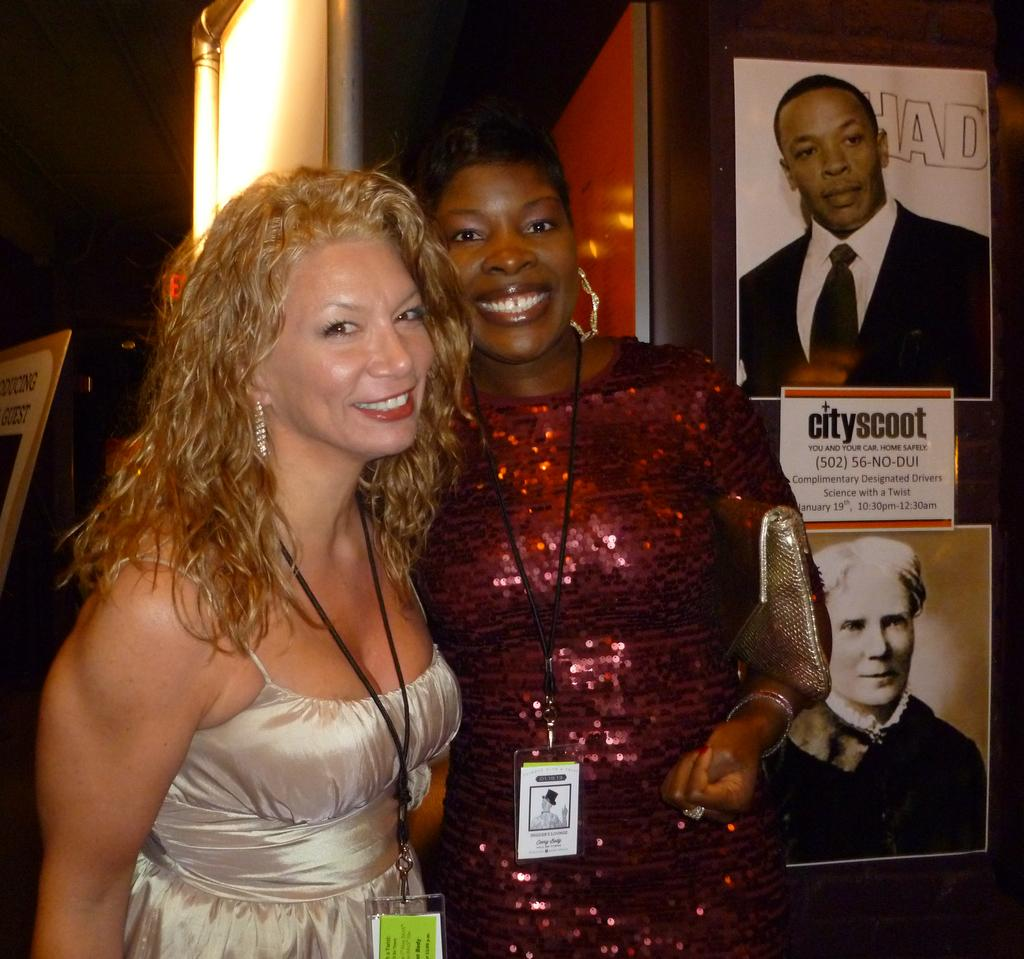How many women are in the image? There are two women standing in the image. What can be seen on the right side of the image? There are photos of people and a paper with text on it on the right side of the image. Where is the paper with text located? The paper is on a wall on the right side of the image. What is on the left side of the image? There is a board on the left side of the image. What direction is the plough facing in the image? There is no plough present in the image. What body part is the woman on the left using to hold the paper on the wall? The provided facts do not specify which body part the woman on the left is using to hold the paper on the wall. 